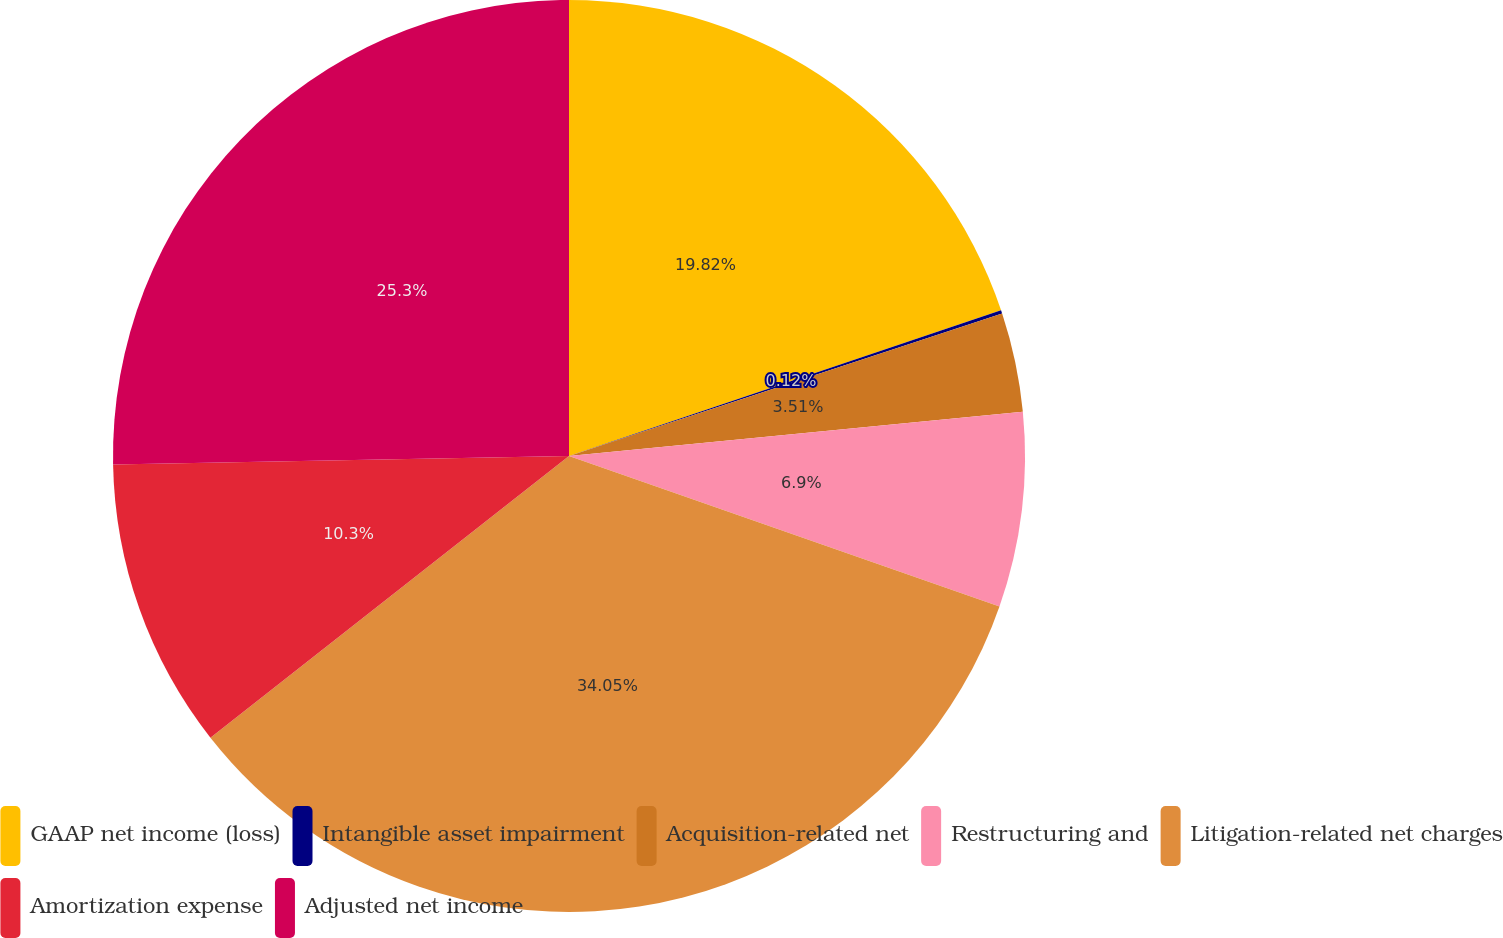Convert chart. <chart><loc_0><loc_0><loc_500><loc_500><pie_chart><fcel>GAAP net income (loss)<fcel>Intangible asset impairment<fcel>Acquisition-related net<fcel>Restructuring and<fcel>Litigation-related net charges<fcel>Amortization expense<fcel>Adjusted net income<nl><fcel>19.82%<fcel>0.12%<fcel>3.51%<fcel>6.9%<fcel>34.05%<fcel>10.3%<fcel>25.3%<nl></chart> 